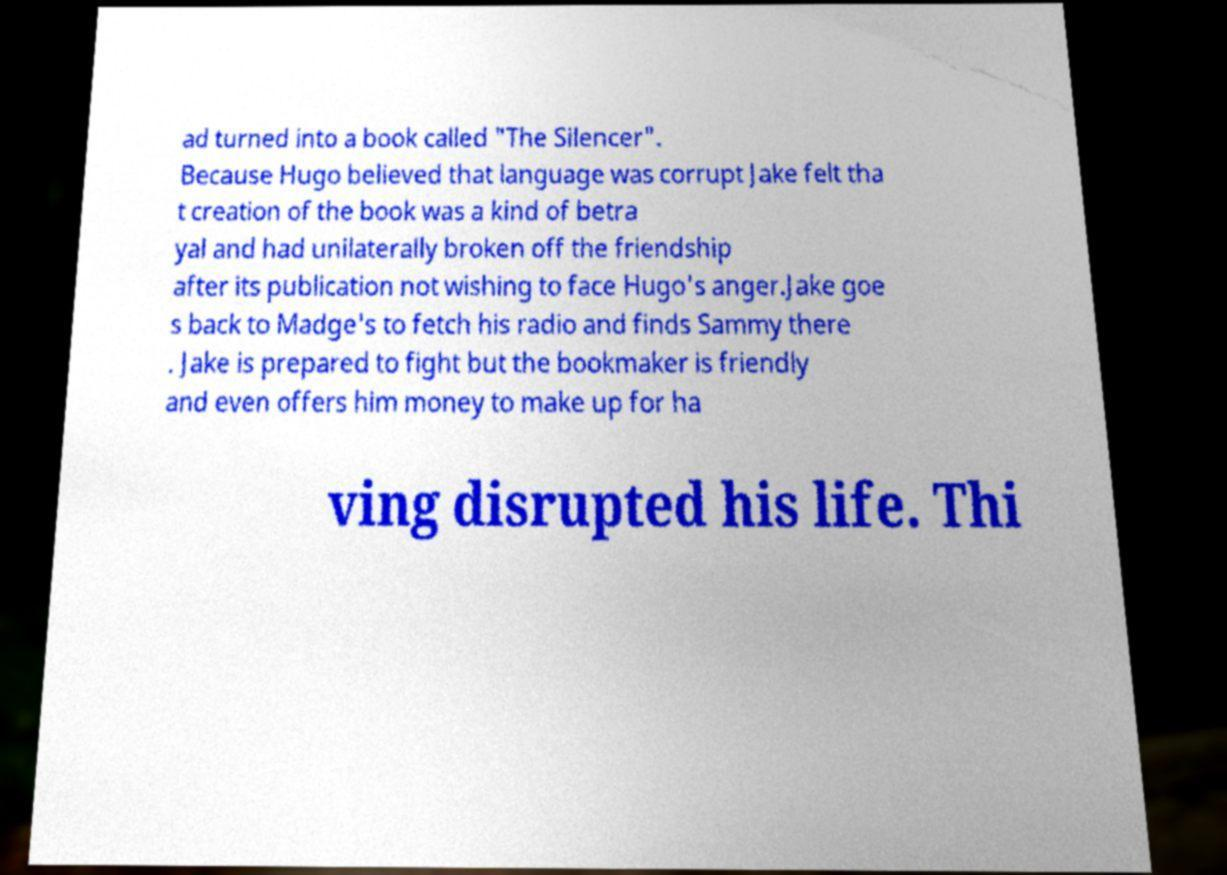There's text embedded in this image that I need extracted. Can you transcribe it verbatim? ad turned into a book called "The Silencer". Because Hugo believed that language was corrupt Jake felt tha t creation of the book was a kind of betra yal and had unilaterally broken off the friendship after its publication not wishing to face Hugo's anger.Jake goe s back to Madge's to fetch his radio and finds Sammy there . Jake is prepared to fight but the bookmaker is friendly and even offers him money to make up for ha ving disrupted his life. Thi 